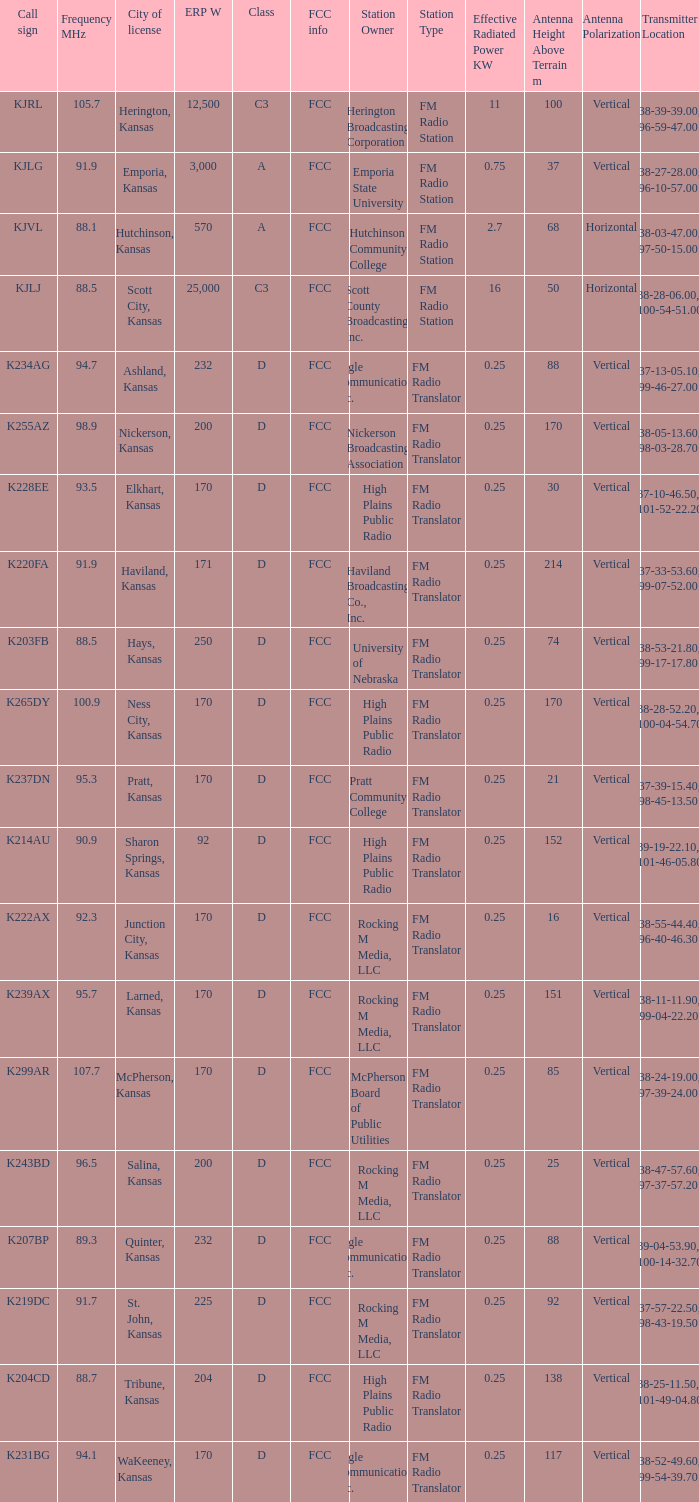Frequency MHz smaller than 95.3, and a Call sign of k234ag is what class? D. 